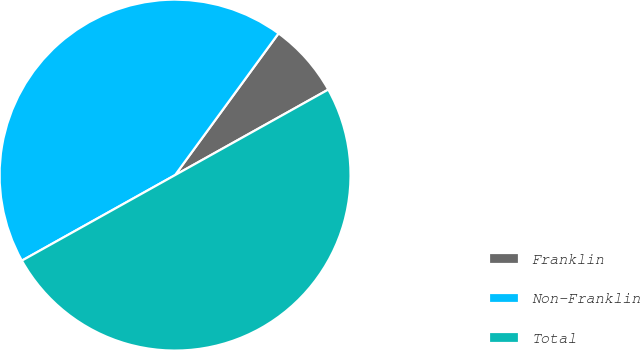<chart> <loc_0><loc_0><loc_500><loc_500><pie_chart><fcel>Franklin<fcel>Non-Franklin<fcel>Total<nl><fcel>6.86%<fcel>43.14%<fcel>50.0%<nl></chart> 